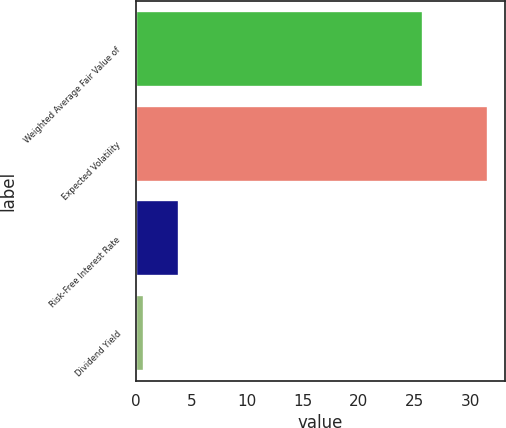Convert chart. <chart><loc_0><loc_0><loc_500><loc_500><bar_chart><fcel>Weighted Average Fair Value of<fcel>Expected Volatility<fcel>Risk-Free Interest Rate<fcel>Dividend Yield<nl><fcel>25.78<fcel>31.54<fcel>3.84<fcel>0.76<nl></chart> 